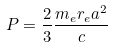<formula> <loc_0><loc_0><loc_500><loc_500>P = \frac { 2 } { 3 } \frac { m _ { e } r _ { e } a ^ { 2 } } { c }</formula> 